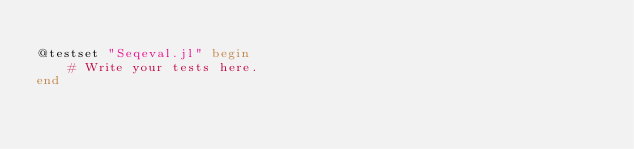Convert code to text. <code><loc_0><loc_0><loc_500><loc_500><_Julia_>
@testset "Seqeval.jl" begin
    # Write your tests here.
end
</code> 